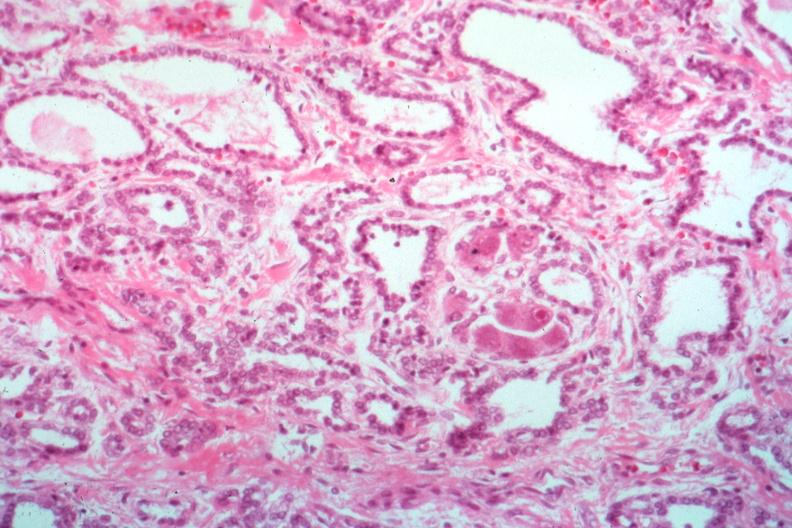s surface present?
Answer the question using a single word or phrase. No 